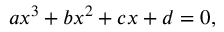<formula> <loc_0><loc_0><loc_500><loc_500>a x ^ { 3 } + b x ^ { 2 } + c x + d = 0 ,</formula> 